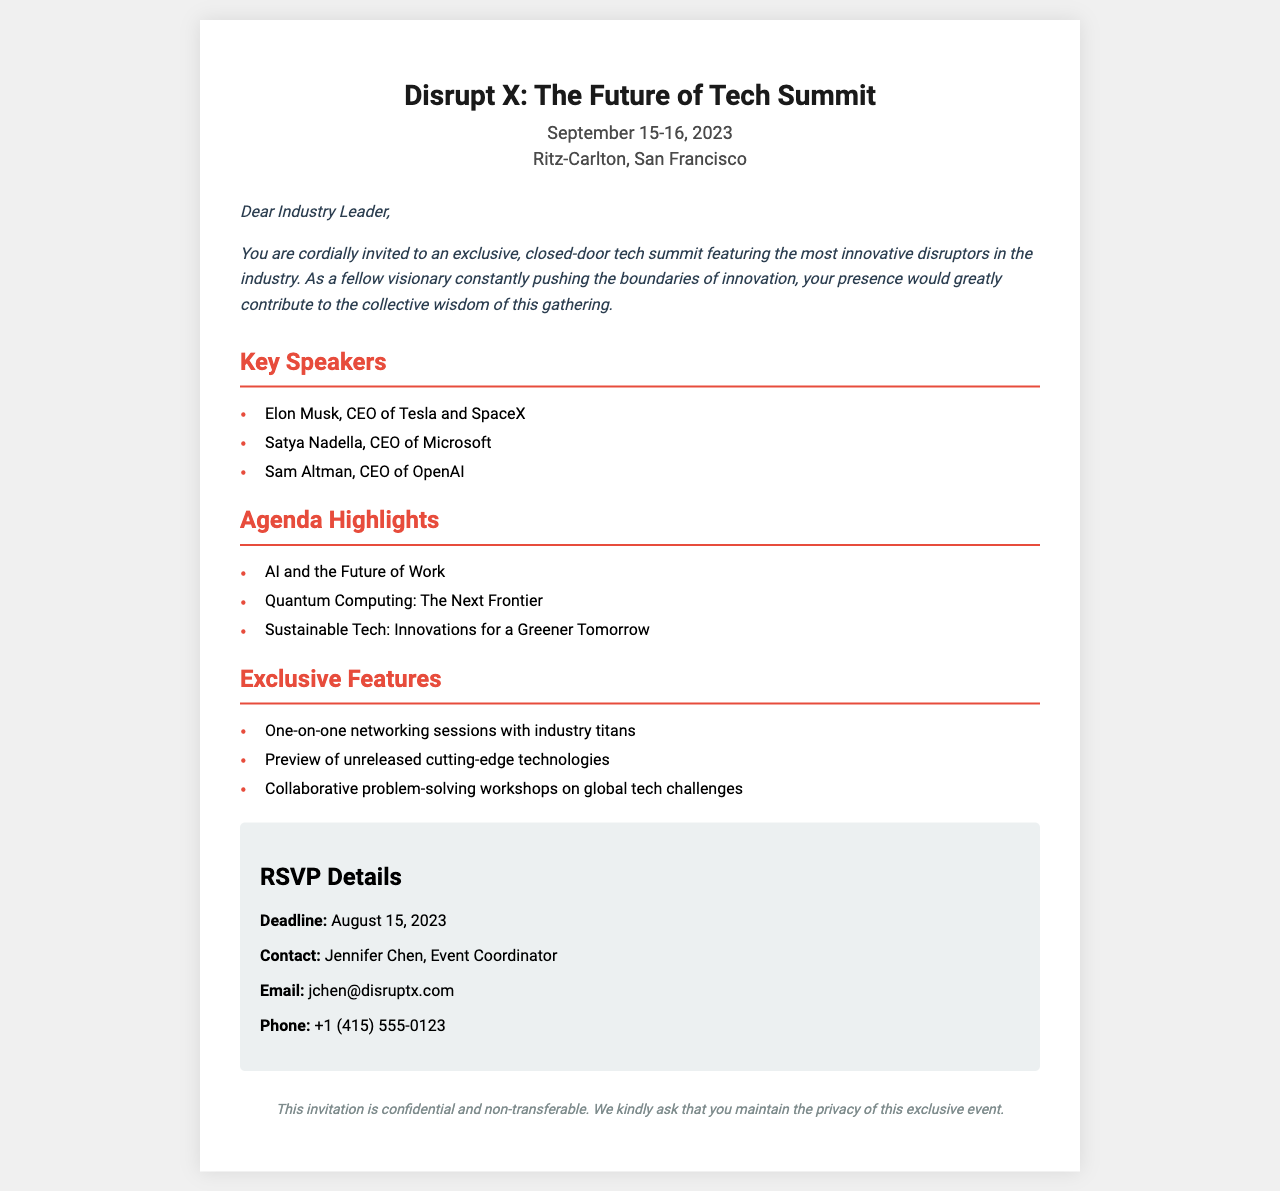What are the dates of the summit? The summit is scheduled for September 15-16, 2023, as mentioned at the top of the document.
Answer: September 15-16, 2023 Who is the CEO of Tesla and SpaceX? Elon Musk is listed as the CEO of Tesla and SpaceX under the Key Speakers section.
Answer: Elon Musk What is the RSVP deadline? The RSVP deadline is provided in the RSVP Details section of the document.
Answer: August 15, 2023 Name one agenda highlight. The agenda highlights include several topics, one of which is clearly mentioned in the document.
Answer: AI and the Future of Work What is required regarding the confidentiality of the invitation? The document specifically requests to maintain the privacy of the event.
Answer: Maintain privacy Which venue is hosting the summit? The Ritz-Carlton in San Francisco is stated as the location at the beginning of the document.
Answer: Ritz-Carlton, San Francisco How many key speakers are listed? The document lists three key speakers in the Key Speakers section.
Answer: Three What is one exclusive feature of the summit? The document outlines a number of exclusive features, indicating one is noted in the Exclusive Features section.
Answer: One-on-one networking sessions with industry titans 